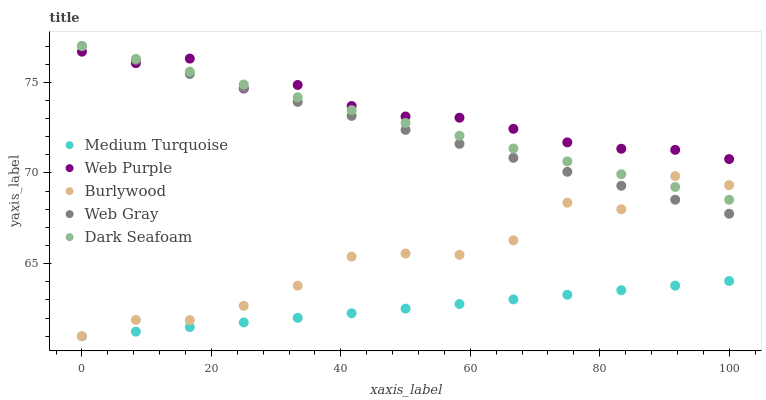Does Medium Turquoise have the minimum area under the curve?
Answer yes or no. Yes. Does Web Purple have the maximum area under the curve?
Answer yes or no. Yes. Does Web Gray have the minimum area under the curve?
Answer yes or no. No. Does Web Gray have the maximum area under the curve?
Answer yes or no. No. Is Medium Turquoise the smoothest?
Answer yes or no. Yes. Is Burlywood the roughest?
Answer yes or no. Yes. Is Web Purple the smoothest?
Answer yes or no. No. Is Web Purple the roughest?
Answer yes or no. No. Does Burlywood have the lowest value?
Answer yes or no. Yes. Does Web Gray have the lowest value?
Answer yes or no. No. Does Dark Seafoam have the highest value?
Answer yes or no. Yes. Does Web Purple have the highest value?
Answer yes or no. No. Is Medium Turquoise less than Web Purple?
Answer yes or no. Yes. Is Web Purple greater than Medium Turquoise?
Answer yes or no. Yes. Does Medium Turquoise intersect Burlywood?
Answer yes or no. Yes. Is Medium Turquoise less than Burlywood?
Answer yes or no. No. Is Medium Turquoise greater than Burlywood?
Answer yes or no. No. Does Medium Turquoise intersect Web Purple?
Answer yes or no. No. 